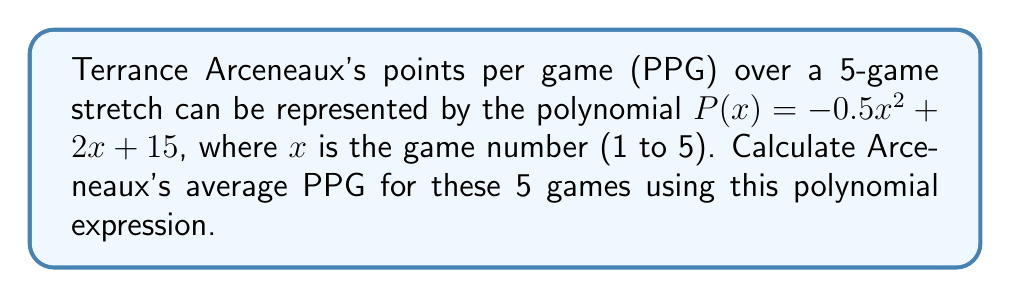Give your solution to this math problem. To calculate the average PPG, we need to:
1. Find the points scored in each game
2. Sum up the total points
3. Divide by the number of games

Step 1: Calculate points for each game:
Game 1: $P(1) = -0.5(1)^2 + 2(1) + 15 = 16.5$
Game 2: $P(2) = -0.5(2)^2 + 2(2) + 15 = 17$
Game 3: $P(3) = -0.5(3)^2 + 2(3) + 15 = 16.5$
Game 4: $P(4) = -0.5(4)^2 + 2(4) + 15 = 15$
Game 5: $P(5) = -0.5(5)^2 + 2(5) + 15 = 12.5$

Step 2: Sum up the total points:
Total points = $16.5 + 17 + 16.5 + 15 + 12.5 = 77.5$

Step 3: Divide by the number of games (5):
Average PPG = $\frac{77.5}{5} = 15.5$

Therefore, Arceneaux's average PPG for these 5 games is 15.5.
Answer: 15.5 PPG 